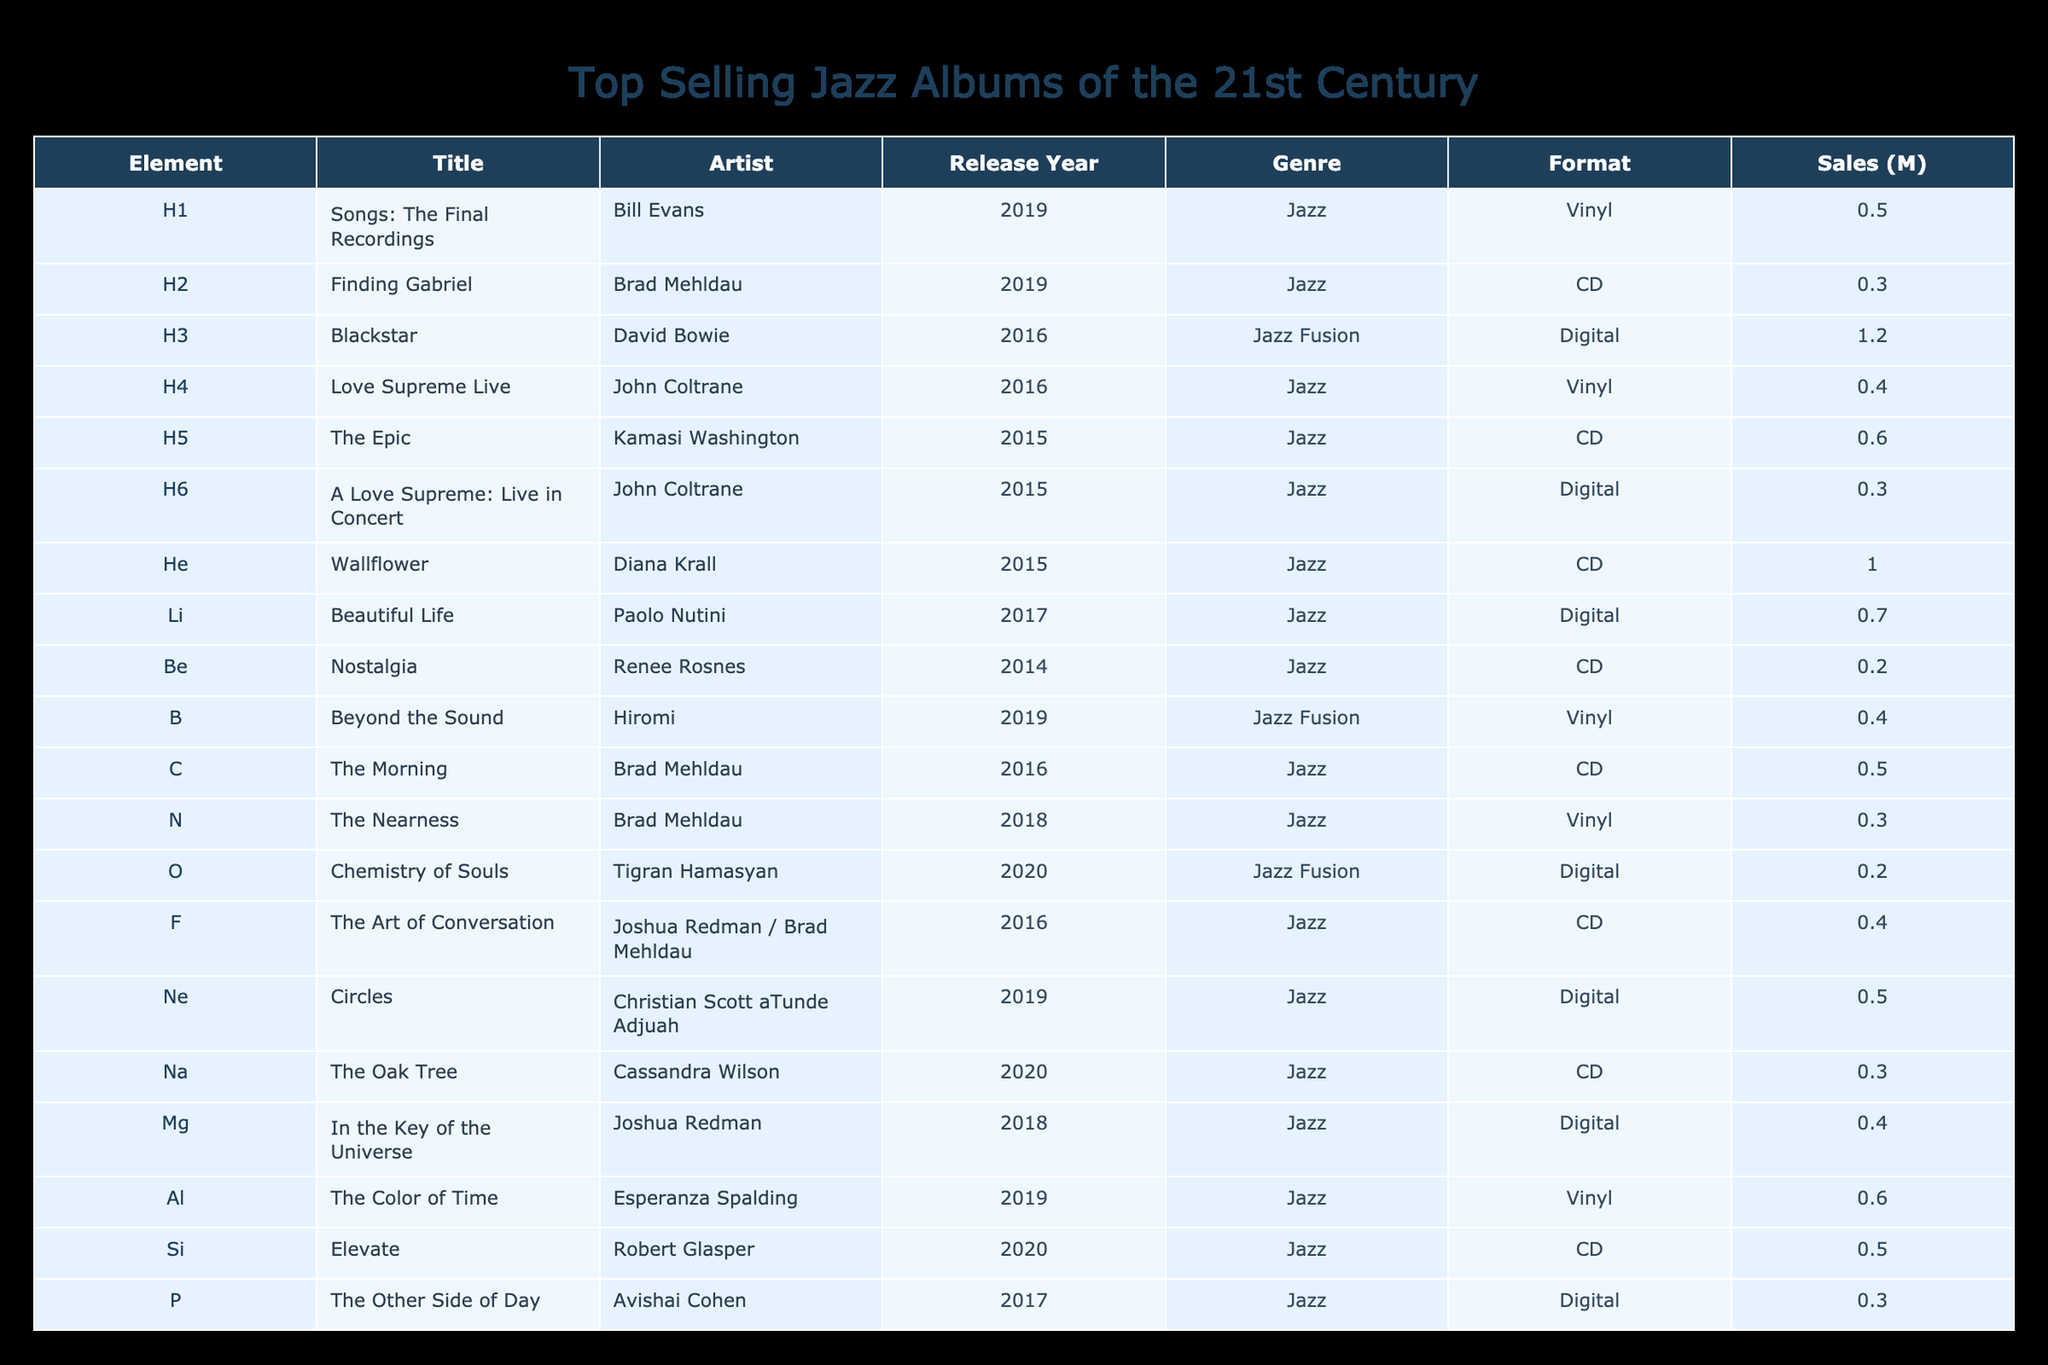What is the highest selling album in this table? The "Blackstar" album by David Bowie is listed with sales of 1.2 million, which is the highest figure in the table when comparing all sales values.
Answer: 1.2 million How many albums were released by Brad Mehldau? The table lists three albums by Brad Mehldau: "Finding Gabriel," "The Morning," and "The Nearness." Counting each instance shows a total of three albums.
Answer: 3 What is the total sales of all albums by John Coltrane in this table? The albums by John Coltrane are "Love Supreme Live" with 0.4 million and "A Love Supreme: Live in Concert" with 0.3 million. Summing these values gives 0.4 + 0.3 = 0.7 million.
Answer: 0.7 million Is "Wallflower" by Diana Krall the highest selling album by a female artist in this table? "Wallflower" has sales of 1.0 million, which is compared to other female artists' albums in the table. The only other female artist's album is "The Color of Time" by Esperanza Spalding with 0.6 million. Therefore, "Wallflower" is indeed the highest.
Answer: Yes What is the average sales of albums released in the year 2016? The albums from 2016 are "Blackstar" (1.2 million), "Love Supreme Live" (0.4 million), "The Morning" (0.5 million), "F" (0.4 million), "Cl" (0.4 million), and "K" (0.6 million). Summing these values gives 1.2 + 0.4 + 0.5 + 0.4 + 0.4 + 0.6 = 3.5 million. Dividing by the number of albums (6) results in an average of 3.5 / 6 = approximately 0.583 million.
Answer: 0.583 million How many Jazz Fusion albums are in the list? There are three entries tagged as Jazz Fusion in the genre column: "Blackstar," "Beyond the Sound," and "Chemistry of Souls." Counting these gives a total of three Jazz Fusion albums.
Answer: 3 